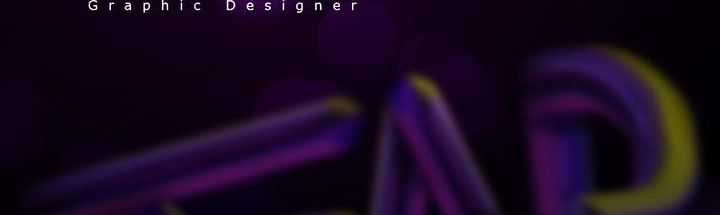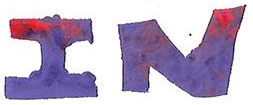What text appears in these images from left to right, separated by a semicolon? ###; IN 